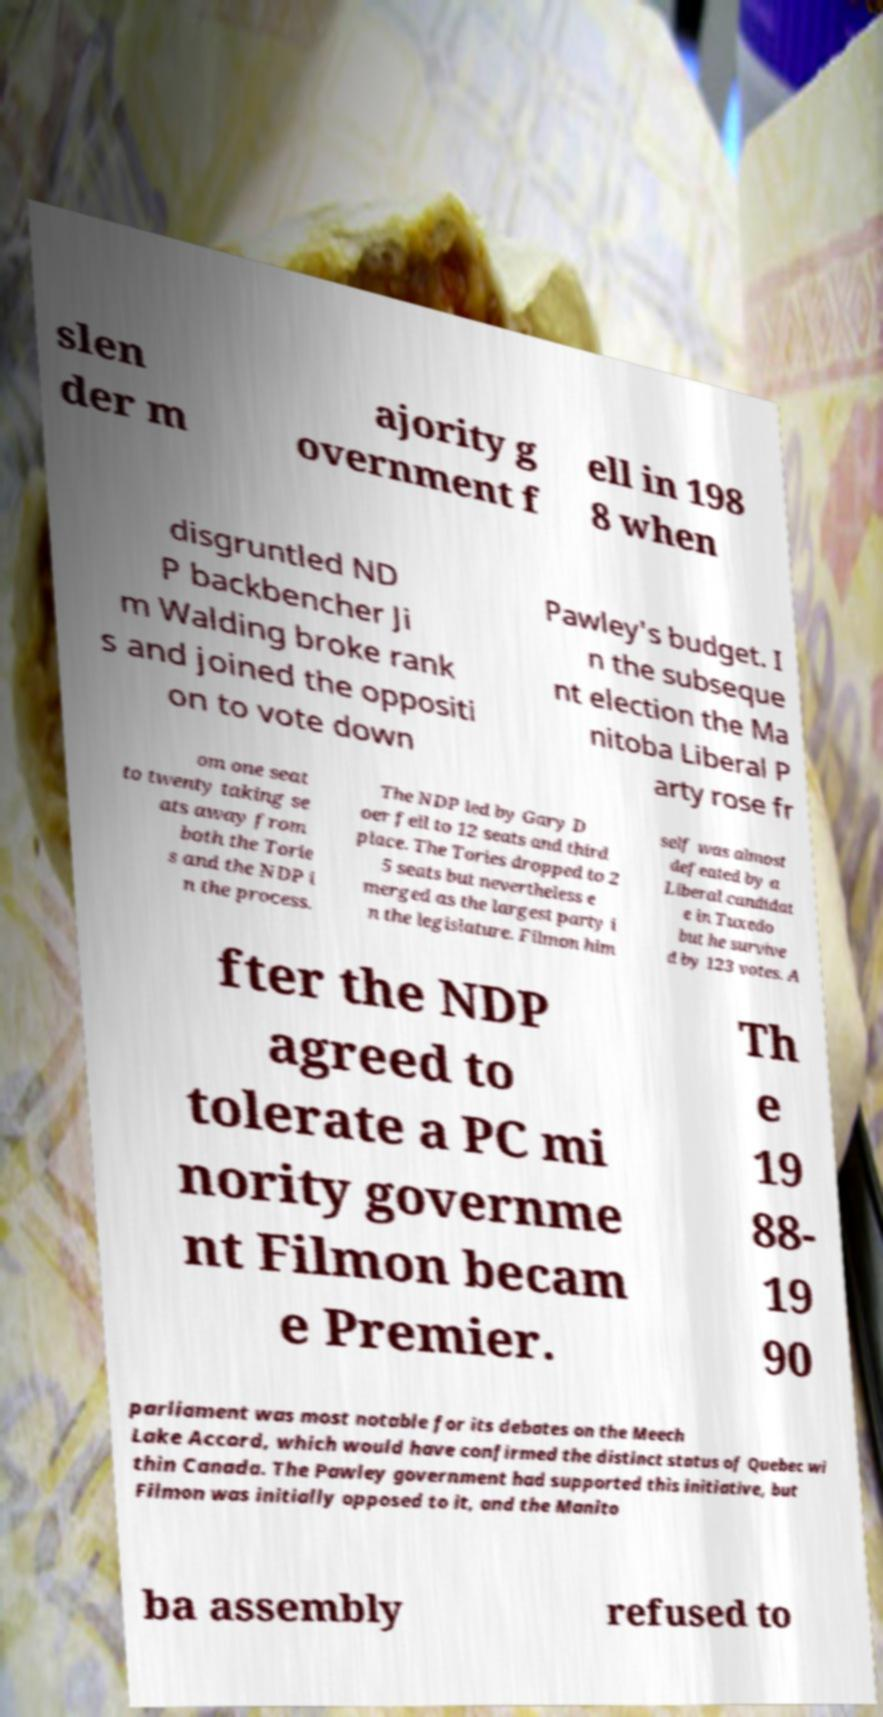Could you extract and type out the text from this image? slen der m ajority g overnment f ell in 198 8 when disgruntled ND P backbencher Ji m Walding broke rank s and joined the oppositi on to vote down Pawley's budget. I n the subseque nt election the Ma nitoba Liberal P arty rose fr om one seat to twenty taking se ats away from both the Torie s and the NDP i n the process. The NDP led by Gary D oer fell to 12 seats and third place. The Tories dropped to 2 5 seats but nevertheless e merged as the largest party i n the legislature. Filmon him self was almost defeated by a Liberal candidat e in Tuxedo but he survive d by 123 votes. A fter the NDP agreed to tolerate a PC mi nority governme nt Filmon becam e Premier. Th e 19 88- 19 90 parliament was most notable for its debates on the Meech Lake Accord, which would have confirmed the distinct status of Quebec wi thin Canada. The Pawley government had supported this initiative, but Filmon was initially opposed to it, and the Manito ba assembly refused to 